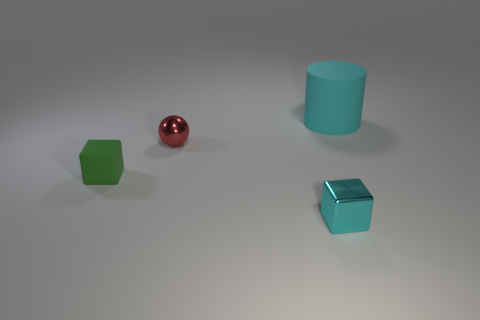Add 1 matte things. How many objects exist? 5 Subtract 0 gray cylinders. How many objects are left? 4 Subtract all tiny cyan things. Subtract all rubber cylinders. How many objects are left? 2 Add 3 cyan metallic cubes. How many cyan metallic cubes are left? 4 Add 1 small cyan metallic cubes. How many small cyan metallic cubes exist? 2 